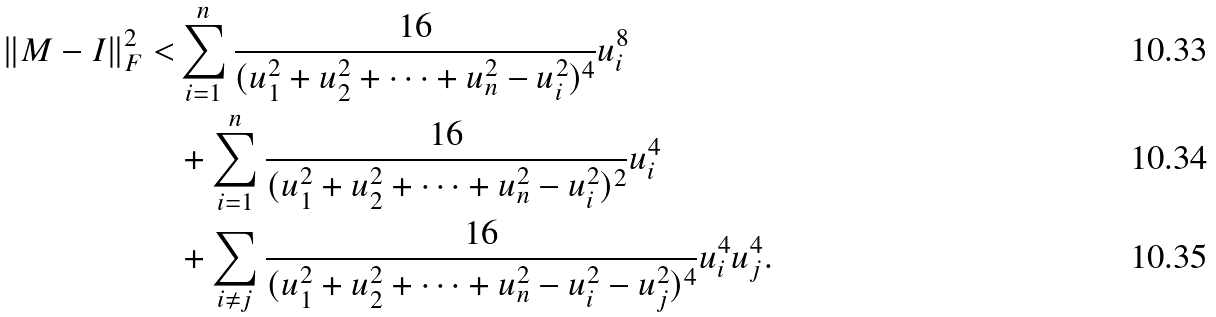Convert formula to latex. <formula><loc_0><loc_0><loc_500><loc_500>\| M - I \| _ { F } ^ { 2 } < & \sum _ { i = 1 } ^ { n } \frac { 1 6 } { ( u _ { 1 } ^ { 2 } + u _ { 2 } ^ { 2 } + \dots + u _ { n } ^ { 2 } - u _ { i } ^ { 2 } ) ^ { 4 } } u _ { i } ^ { 8 } \\ & + \sum _ { i = 1 } ^ { n } \frac { 1 6 } { ( u _ { 1 } ^ { 2 } + u _ { 2 } ^ { 2 } + \dots + u _ { n } ^ { 2 } - u _ { i } ^ { 2 } ) ^ { 2 } } u _ { i } ^ { 4 } \\ & + \sum _ { i \neq j } \frac { 1 6 } { ( u _ { 1 } ^ { 2 } + u _ { 2 } ^ { 2 } + \dots + u _ { n } ^ { 2 } - u _ { i } ^ { 2 } - u _ { j } ^ { 2 } ) ^ { 4 } } u _ { i } ^ { 4 } u _ { j } ^ { 4 } .</formula> 